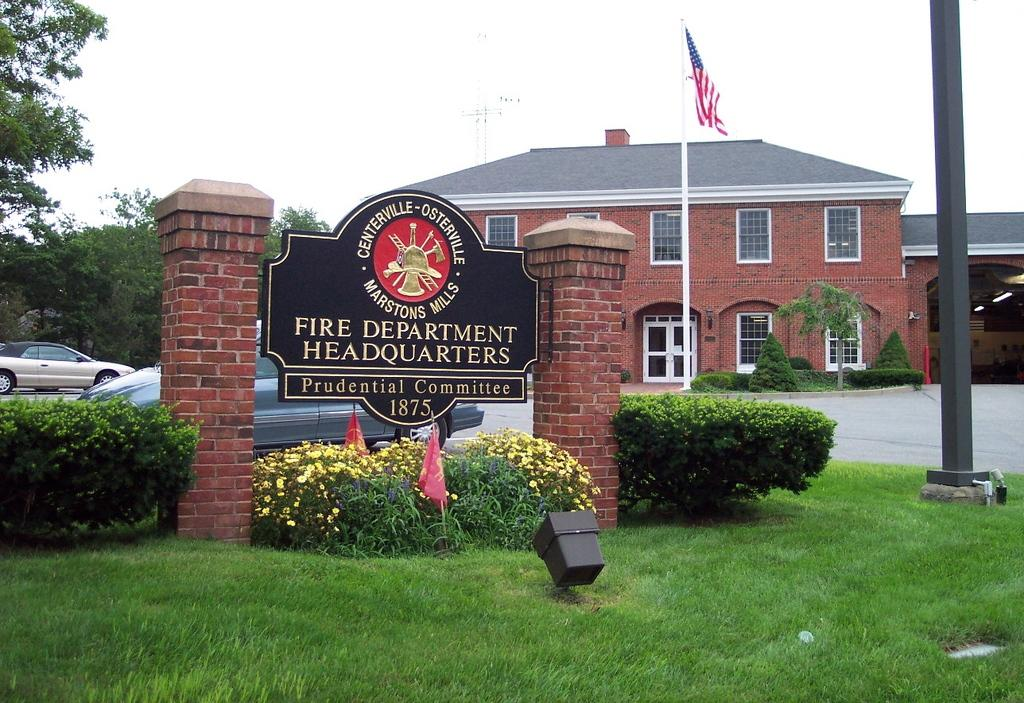What types of living organisms can be seen in the foreground of the image? Plants, flowers, and grass can be seen in the foreground of the image. What objects are present in the foreground of the image? Flags, a light, a board with text, and a pole can be seen in the foreground of the image. What can be seen in the background of the image? Cars, houses, a flagpole, trees, and sky are visible in the background of the image. What scent can be detected from the flowers in the image? The image does not provide information about the scent of the flowers, so it cannot be determined from the image. Is the board in the foreground of the image a work of fiction? The image does not provide information about the content of the board, so it cannot be determined if it is a work of fiction or not. 